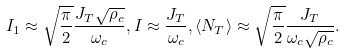Convert formula to latex. <formula><loc_0><loc_0><loc_500><loc_500>I _ { 1 } & \approx \sqrt { \frac { \pi } { 2 } } \frac { J _ { T } \sqrt { \rho _ { c } } } { \omega _ { c } } , I \approx \frac { J _ { T } } { \omega _ { c } } , \langle N _ { T } \rangle \approx \sqrt { \frac { \pi } { 2 } } \frac { J _ { T } } { \omega _ { c } \sqrt { \rho _ { c } } } .</formula> 